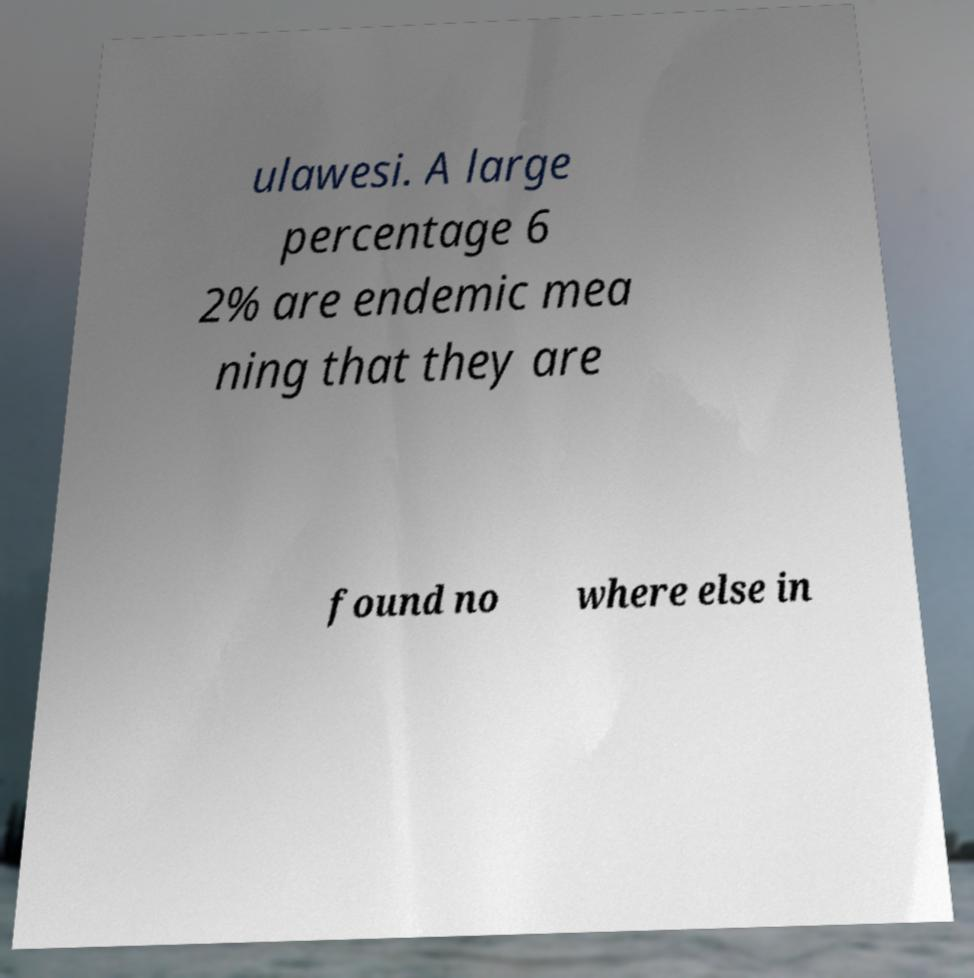What messages or text are displayed in this image? I need them in a readable, typed format. ulawesi. A large percentage 6 2% are endemic mea ning that they are found no where else in 